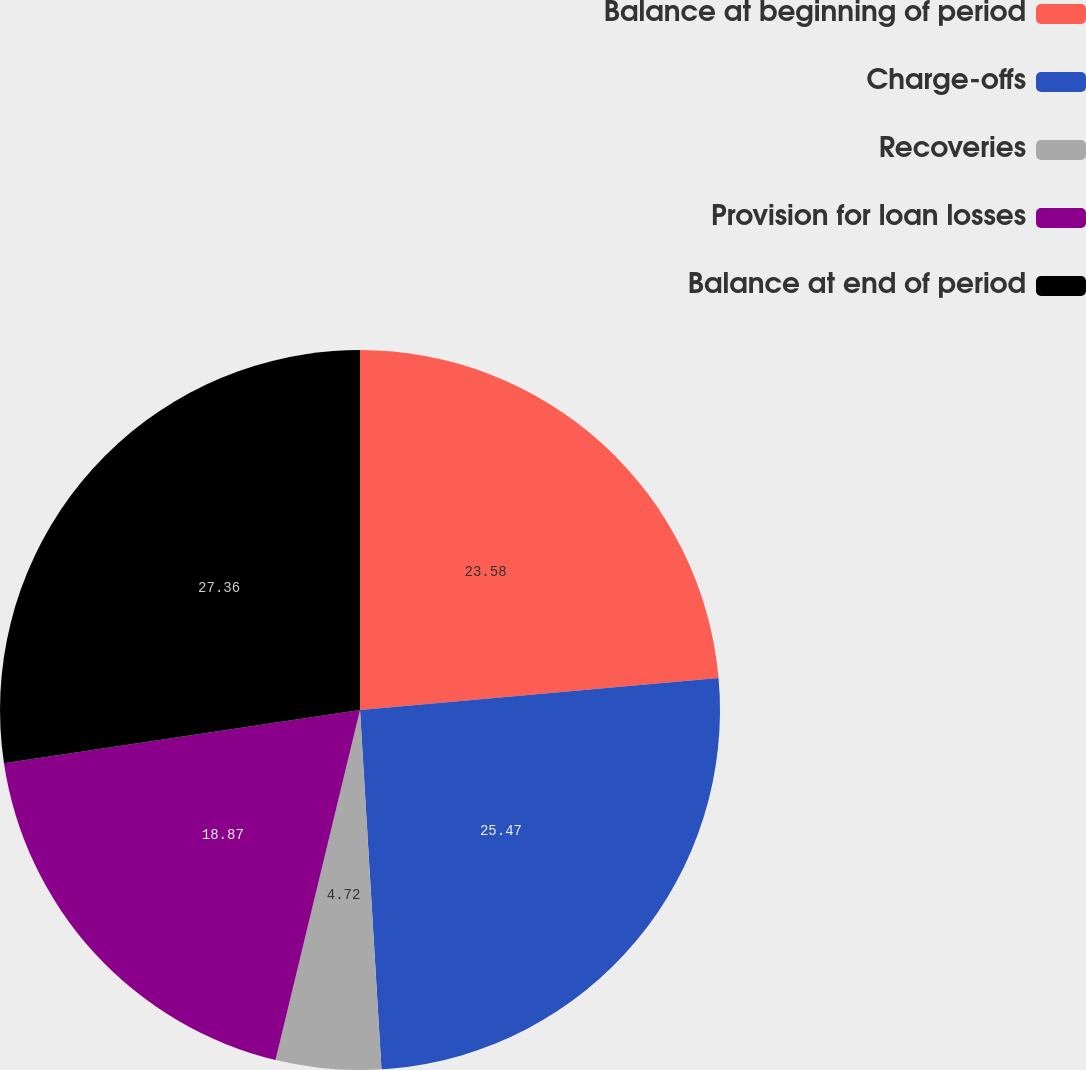Convert chart to OTSL. <chart><loc_0><loc_0><loc_500><loc_500><pie_chart><fcel>Balance at beginning of period<fcel>Charge-offs<fcel>Recoveries<fcel>Provision for loan losses<fcel>Balance at end of period<nl><fcel>23.58%<fcel>25.47%<fcel>4.72%<fcel>18.87%<fcel>27.36%<nl></chart> 